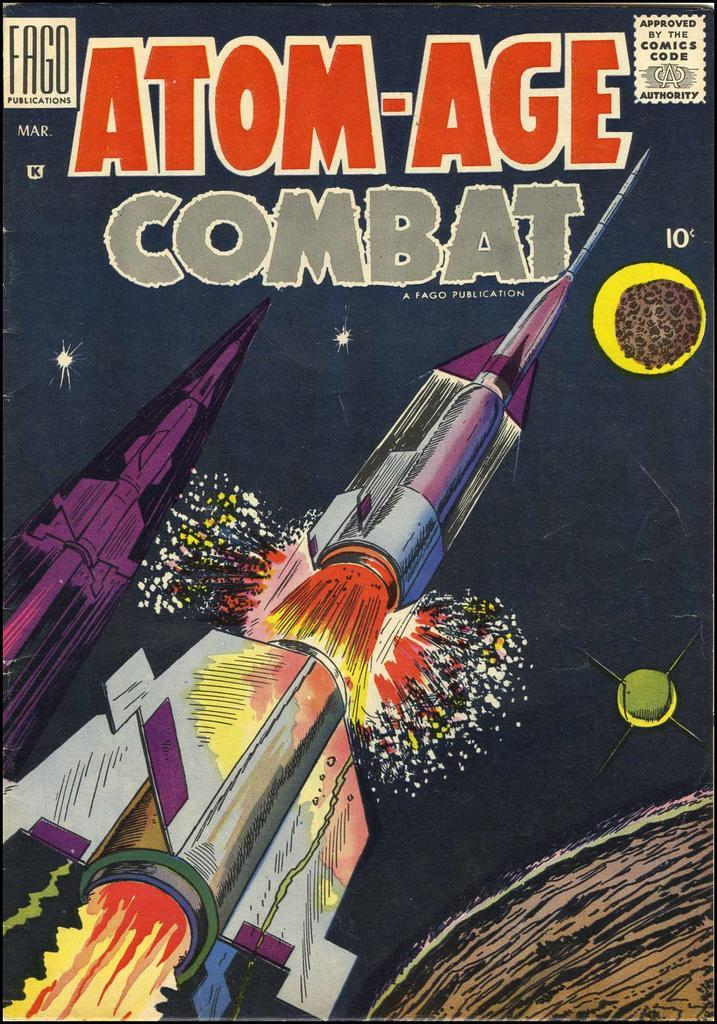<image>
Summarize the visual content of the image. A ten cent comic called Atom-Age Combat is produced by Fago Publications. 